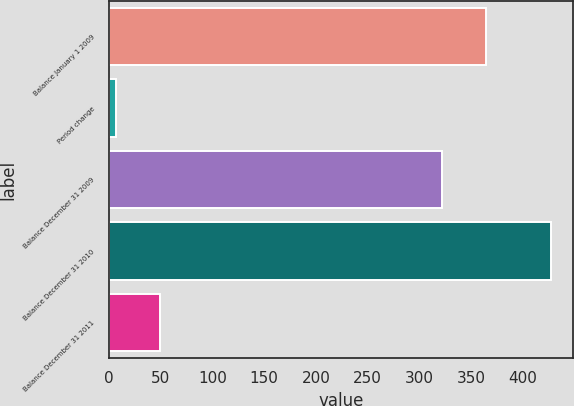Convert chart to OTSL. <chart><loc_0><loc_0><loc_500><loc_500><bar_chart><fcel>Balance January 1 2009<fcel>Period change<fcel>Balance December 31 2009<fcel>Balance December 31 2010<fcel>Balance December 31 2011<nl><fcel>364<fcel>7<fcel>322<fcel>427<fcel>49<nl></chart> 